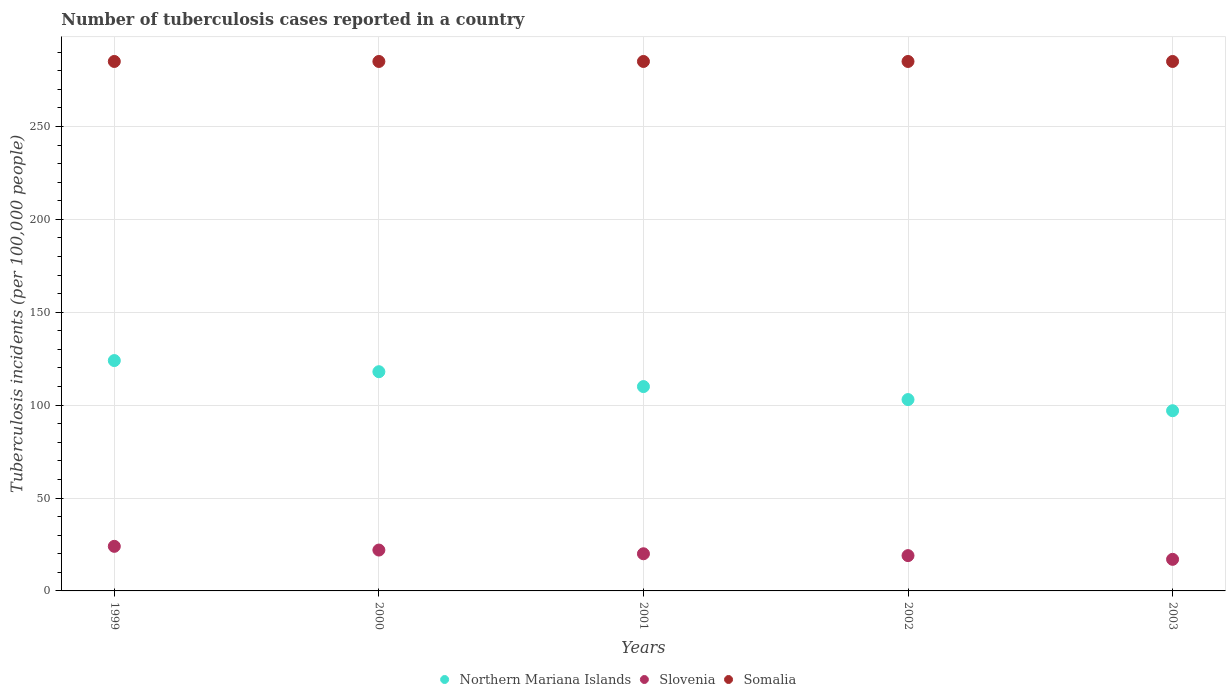Is the number of dotlines equal to the number of legend labels?
Make the answer very short. Yes. What is the number of tuberculosis cases reported in in Somalia in 1999?
Your answer should be compact. 285. Across all years, what is the maximum number of tuberculosis cases reported in in Somalia?
Offer a terse response. 285. Across all years, what is the minimum number of tuberculosis cases reported in in Northern Mariana Islands?
Keep it short and to the point. 97. In which year was the number of tuberculosis cases reported in in Northern Mariana Islands maximum?
Provide a succinct answer. 1999. In which year was the number of tuberculosis cases reported in in Slovenia minimum?
Your answer should be very brief. 2003. What is the total number of tuberculosis cases reported in in Slovenia in the graph?
Your answer should be very brief. 102. What is the average number of tuberculosis cases reported in in Slovenia per year?
Your response must be concise. 20.4. In the year 2000, what is the difference between the number of tuberculosis cases reported in in Somalia and number of tuberculosis cases reported in in Slovenia?
Your answer should be very brief. 263. What is the ratio of the number of tuberculosis cases reported in in Northern Mariana Islands in 1999 to that in 2003?
Provide a succinct answer. 1.28. Is the number of tuberculosis cases reported in in Northern Mariana Islands in 1999 less than that in 2001?
Make the answer very short. No. Is the difference between the number of tuberculosis cases reported in in Somalia in 2001 and 2003 greater than the difference between the number of tuberculosis cases reported in in Slovenia in 2001 and 2003?
Give a very brief answer. No. What is the difference between the highest and the second highest number of tuberculosis cases reported in in Slovenia?
Provide a short and direct response. 2. Is the sum of the number of tuberculosis cases reported in in Northern Mariana Islands in 2000 and 2003 greater than the maximum number of tuberculosis cases reported in in Slovenia across all years?
Your answer should be compact. Yes. Is it the case that in every year, the sum of the number of tuberculosis cases reported in in Northern Mariana Islands and number of tuberculosis cases reported in in Somalia  is greater than the number of tuberculosis cases reported in in Slovenia?
Your answer should be compact. Yes. Does the number of tuberculosis cases reported in in Northern Mariana Islands monotonically increase over the years?
Give a very brief answer. No. Is the number of tuberculosis cases reported in in Slovenia strictly less than the number of tuberculosis cases reported in in Northern Mariana Islands over the years?
Your answer should be very brief. Yes. How many dotlines are there?
Provide a short and direct response. 3. How many years are there in the graph?
Your response must be concise. 5. Does the graph contain any zero values?
Offer a terse response. No. Does the graph contain grids?
Give a very brief answer. Yes. How are the legend labels stacked?
Make the answer very short. Horizontal. What is the title of the graph?
Provide a succinct answer. Number of tuberculosis cases reported in a country. What is the label or title of the X-axis?
Your answer should be very brief. Years. What is the label or title of the Y-axis?
Offer a terse response. Tuberculosis incidents (per 100,0 people). What is the Tuberculosis incidents (per 100,000 people) in Northern Mariana Islands in 1999?
Your answer should be compact. 124. What is the Tuberculosis incidents (per 100,000 people) in Somalia in 1999?
Your answer should be compact. 285. What is the Tuberculosis incidents (per 100,000 people) in Northern Mariana Islands in 2000?
Offer a terse response. 118. What is the Tuberculosis incidents (per 100,000 people) of Slovenia in 2000?
Provide a succinct answer. 22. What is the Tuberculosis incidents (per 100,000 people) of Somalia in 2000?
Your answer should be compact. 285. What is the Tuberculosis incidents (per 100,000 people) in Northern Mariana Islands in 2001?
Keep it short and to the point. 110. What is the Tuberculosis incidents (per 100,000 people) of Somalia in 2001?
Your answer should be very brief. 285. What is the Tuberculosis incidents (per 100,000 people) in Northern Mariana Islands in 2002?
Offer a terse response. 103. What is the Tuberculosis incidents (per 100,000 people) in Slovenia in 2002?
Offer a terse response. 19. What is the Tuberculosis incidents (per 100,000 people) in Somalia in 2002?
Give a very brief answer. 285. What is the Tuberculosis incidents (per 100,000 people) in Northern Mariana Islands in 2003?
Offer a terse response. 97. What is the Tuberculosis incidents (per 100,000 people) in Slovenia in 2003?
Give a very brief answer. 17. What is the Tuberculosis incidents (per 100,000 people) of Somalia in 2003?
Provide a succinct answer. 285. Across all years, what is the maximum Tuberculosis incidents (per 100,000 people) of Northern Mariana Islands?
Your response must be concise. 124. Across all years, what is the maximum Tuberculosis incidents (per 100,000 people) in Slovenia?
Give a very brief answer. 24. Across all years, what is the maximum Tuberculosis incidents (per 100,000 people) in Somalia?
Offer a terse response. 285. Across all years, what is the minimum Tuberculosis incidents (per 100,000 people) in Northern Mariana Islands?
Provide a succinct answer. 97. Across all years, what is the minimum Tuberculosis incidents (per 100,000 people) in Somalia?
Ensure brevity in your answer.  285. What is the total Tuberculosis incidents (per 100,000 people) of Northern Mariana Islands in the graph?
Give a very brief answer. 552. What is the total Tuberculosis incidents (per 100,000 people) of Slovenia in the graph?
Your answer should be very brief. 102. What is the total Tuberculosis incidents (per 100,000 people) in Somalia in the graph?
Your answer should be very brief. 1425. What is the difference between the Tuberculosis incidents (per 100,000 people) of Northern Mariana Islands in 1999 and that in 2000?
Provide a short and direct response. 6. What is the difference between the Tuberculosis incidents (per 100,000 people) of Somalia in 1999 and that in 2000?
Keep it short and to the point. 0. What is the difference between the Tuberculosis incidents (per 100,000 people) of Northern Mariana Islands in 1999 and that in 2001?
Your answer should be compact. 14. What is the difference between the Tuberculosis incidents (per 100,000 people) of Slovenia in 1999 and that in 2001?
Offer a very short reply. 4. What is the difference between the Tuberculosis incidents (per 100,000 people) of Slovenia in 1999 and that in 2002?
Make the answer very short. 5. What is the difference between the Tuberculosis incidents (per 100,000 people) of Somalia in 1999 and that in 2002?
Keep it short and to the point. 0. What is the difference between the Tuberculosis incidents (per 100,000 people) of Northern Mariana Islands in 1999 and that in 2003?
Give a very brief answer. 27. What is the difference between the Tuberculosis incidents (per 100,000 people) of Somalia in 1999 and that in 2003?
Offer a terse response. 0. What is the difference between the Tuberculosis incidents (per 100,000 people) in Northern Mariana Islands in 2000 and that in 2001?
Your response must be concise. 8. What is the difference between the Tuberculosis incidents (per 100,000 people) of Slovenia in 2000 and that in 2001?
Offer a very short reply. 2. What is the difference between the Tuberculosis incidents (per 100,000 people) of Northern Mariana Islands in 2000 and that in 2002?
Your answer should be compact. 15. What is the difference between the Tuberculosis incidents (per 100,000 people) of Northern Mariana Islands in 2000 and that in 2003?
Give a very brief answer. 21. What is the difference between the Tuberculosis incidents (per 100,000 people) of Slovenia in 2000 and that in 2003?
Give a very brief answer. 5. What is the difference between the Tuberculosis incidents (per 100,000 people) of Northern Mariana Islands in 2001 and that in 2002?
Give a very brief answer. 7. What is the difference between the Tuberculosis incidents (per 100,000 people) in Northern Mariana Islands in 2002 and that in 2003?
Provide a short and direct response. 6. What is the difference between the Tuberculosis incidents (per 100,000 people) in Slovenia in 2002 and that in 2003?
Keep it short and to the point. 2. What is the difference between the Tuberculosis incidents (per 100,000 people) of Somalia in 2002 and that in 2003?
Your answer should be very brief. 0. What is the difference between the Tuberculosis incidents (per 100,000 people) of Northern Mariana Islands in 1999 and the Tuberculosis incidents (per 100,000 people) of Slovenia in 2000?
Give a very brief answer. 102. What is the difference between the Tuberculosis incidents (per 100,000 people) of Northern Mariana Islands in 1999 and the Tuberculosis incidents (per 100,000 people) of Somalia in 2000?
Provide a short and direct response. -161. What is the difference between the Tuberculosis incidents (per 100,000 people) of Slovenia in 1999 and the Tuberculosis incidents (per 100,000 people) of Somalia in 2000?
Offer a very short reply. -261. What is the difference between the Tuberculosis incidents (per 100,000 people) of Northern Mariana Islands in 1999 and the Tuberculosis incidents (per 100,000 people) of Slovenia in 2001?
Ensure brevity in your answer.  104. What is the difference between the Tuberculosis incidents (per 100,000 people) of Northern Mariana Islands in 1999 and the Tuberculosis incidents (per 100,000 people) of Somalia in 2001?
Your answer should be very brief. -161. What is the difference between the Tuberculosis incidents (per 100,000 people) of Slovenia in 1999 and the Tuberculosis incidents (per 100,000 people) of Somalia in 2001?
Ensure brevity in your answer.  -261. What is the difference between the Tuberculosis incidents (per 100,000 people) in Northern Mariana Islands in 1999 and the Tuberculosis incidents (per 100,000 people) in Slovenia in 2002?
Your response must be concise. 105. What is the difference between the Tuberculosis incidents (per 100,000 people) in Northern Mariana Islands in 1999 and the Tuberculosis incidents (per 100,000 people) in Somalia in 2002?
Keep it short and to the point. -161. What is the difference between the Tuberculosis incidents (per 100,000 people) in Slovenia in 1999 and the Tuberculosis incidents (per 100,000 people) in Somalia in 2002?
Your answer should be compact. -261. What is the difference between the Tuberculosis incidents (per 100,000 people) in Northern Mariana Islands in 1999 and the Tuberculosis incidents (per 100,000 people) in Slovenia in 2003?
Your answer should be compact. 107. What is the difference between the Tuberculosis incidents (per 100,000 people) in Northern Mariana Islands in 1999 and the Tuberculosis incidents (per 100,000 people) in Somalia in 2003?
Make the answer very short. -161. What is the difference between the Tuberculosis incidents (per 100,000 people) of Slovenia in 1999 and the Tuberculosis incidents (per 100,000 people) of Somalia in 2003?
Make the answer very short. -261. What is the difference between the Tuberculosis incidents (per 100,000 people) of Northern Mariana Islands in 2000 and the Tuberculosis incidents (per 100,000 people) of Slovenia in 2001?
Give a very brief answer. 98. What is the difference between the Tuberculosis incidents (per 100,000 people) of Northern Mariana Islands in 2000 and the Tuberculosis incidents (per 100,000 people) of Somalia in 2001?
Your response must be concise. -167. What is the difference between the Tuberculosis incidents (per 100,000 people) in Slovenia in 2000 and the Tuberculosis incidents (per 100,000 people) in Somalia in 2001?
Provide a short and direct response. -263. What is the difference between the Tuberculosis incidents (per 100,000 people) in Northern Mariana Islands in 2000 and the Tuberculosis incidents (per 100,000 people) in Slovenia in 2002?
Your response must be concise. 99. What is the difference between the Tuberculosis incidents (per 100,000 people) in Northern Mariana Islands in 2000 and the Tuberculosis incidents (per 100,000 people) in Somalia in 2002?
Provide a short and direct response. -167. What is the difference between the Tuberculosis incidents (per 100,000 people) of Slovenia in 2000 and the Tuberculosis incidents (per 100,000 people) of Somalia in 2002?
Provide a succinct answer. -263. What is the difference between the Tuberculosis incidents (per 100,000 people) of Northern Mariana Islands in 2000 and the Tuberculosis incidents (per 100,000 people) of Slovenia in 2003?
Offer a terse response. 101. What is the difference between the Tuberculosis incidents (per 100,000 people) of Northern Mariana Islands in 2000 and the Tuberculosis incidents (per 100,000 people) of Somalia in 2003?
Provide a short and direct response. -167. What is the difference between the Tuberculosis incidents (per 100,000 people) in Slovenia in 2000 and the Tuberculosis incidents (per 100,000 people) in Somalia in 2003?
Give a very brief answer. -263. What is the difference between the Tuberculosis incidents (per 100,000 people) of Northern Mariana Islands in 2001 and the Tuberculosis incidents (per 100,000 people) of Slovenia in 2002?
Provide a short and direct response. 91. What is the difference between the Tuberculosis incidents (per 100,000 people) in Northern Mariana Islands in 2001 and the Tuberculosis incidents (per 100,000 people) in Somalia in 2002?
Your response must be concise. -175. What is the difference between the Tuberculosis incidents (per 100,000 people) in Slovenia in 2001 and the Tuberculosis incidents (per 100,000 people) in Somalia in 2002?
Provide a short and direct response. -265. What is the difference between the Tuberculosis incidents (per 100,000 people) in Northern Mariana Islands in 2001 and the Tuberculosis incidents (per 100,000 people) in Slovenia in 2003?
Provide a short and direct response. 93. What is the difference between the Tuberculosis incidents (per 100,000 people) of Northern Mariana Islands in 2001 and the Tuberculosis incidents (per 100,000 people) of Somalia in 2003?
Your response must be concise. -175. What is the difference between the Tuberculosis incidents (per 100,000 people) in Slovenia in 2001 and the Tuberculosis incidents (per 100,000 people) in Somalia in 2003?
Your response must be concise. -265. What is the difference between the Tuberculosis incidents (per 100,000 people) in Northern Mariana Islands in 2002 and the Tuberculosis incidents (per 100,000 people) in Slovenia in 2003?
Make the answer very short. 86. What is the difference between the Tuberculosis incidents (per 100,000 people) of Northern Mariana Islands in 2002 and the Tuberculosis incidents (per 100,000 people) of Somalia in 2003?
Keep it short and to the point. -182. What is the difference between the Tuberculosis incidents (per 100,000 people) of Slovenia in 2002 and the Tuberculosis incidents (per 100,000 people) of Somalia in 2003?
Keep it short and to the point. -266. What is the average Tuberculosis incidents (per 100,000 people) in Northern Mariana Islands per year?
Keep it short and to the point. 110.4. What is the average Tuberculosis incidents (per 100,000 people) of Slovenia per year?
Provide a succinct answer. 20.4. What is the average Tuberculosis incidents (per 100,000 people) of Somalia per year?
Provide a short and direct response. 285. In the year 1999, what is the difference between the Tuberculosis incidents (per 100,000 people) in Northern Mariana Islands and Tuberculosis incidents (per 100,000 people) in Somalia?
Provide a succinct answer. -161. In the year 1999, what is the difference between the Tuberculosis incidents (per 100,000 people) of Slovenia and Tuberculosis incidents (per 100,000 people) of Somalia?
Give a very brief answer. -261. In the year 2000, what is the difference between the Tuberculosis incidents (per 100,000 people) in Northern Mariana Islands and Tuberculosis incidents (per 100,000 people) in Slovenia?
Provide a succinct answer. 96. In the year 2000, what is the difference between the Tuberculosis incidents (per 100,000 people) of Northern Mariana Islands and Tuberculosis incidents (per 100,000 people) of Somalia?
Your response must be concise. -167. In the year 2000, what is the difference between the Tuberculosis incidents (per 100,000 people) in Slovenia and Tuberculosis incidents (per 100,000 people) in Somalia?
Offer a very short reply. -263. In the year 2001, what is the difference between the Tuberculosis incidents (per 100,000 people) of Northern Mariana Islands and Tuberculosis incidents (per 100,000 people) of Somalia?
Give a very brief answer. -175. In the year 2001, what is the difference between the Tuberculosis incidents (per 100,000 people) of Slovenia and Tuberculosis incidents (per 100,000 people) of Somalia?
Your answer should be compact. -265. In the year 2002, what is the difference between the Tuberculosis incidents (per 100,000 people) in Northern Mariana Islands and Tuberculosis incidents (per 100,000 people) in Somalia?
Provide a short and direct response. -182. In the year 2002, what is the difference between the Tuberculosis incidents (per 100,000 people) of Slovenia and Tuberculosis incidents (per 100,000 people) of Somalia?
Offer a terse response. -266. In the year 2003, what is the difference between the Tuberculosis incidents (per 100,000 people) of Northern Mariana Islands and Tuberculosis incidents (per 100,000 people) of Somalia?
Offer a terse response. -188. In the year 2003, what is the difference between the Tuberculosis incidents (per 100,000 people) in Slovenia and Tuberculosis incidents (per 100,000 people) in Somalia?
Provide a succinct answer. -268. What is the ratio of the Tuberculosis incidents (per 100,000 people) in Northern Mariana Islands in 1999 to that in 2000?
Keep it short and to the point. 1.05. What is the ratio of the Tuberculosis incidents (per 100,000 people) of Somalia in 1999 to that in 2000?
Offer a terse response. 1. What is the ratio of the Tuberculosis incidents (per 100,000 people) of Northern Mariana Islands in 1999 to that in 2001?
Your response must be concise. 1.13. What is the ratio of the Tuberculosis incidents (per 100,000 people) of Slovenia in 1999 to that in 2001?
Ensure brevity in your answer.  1.2. What is the ratio of the Tuberculosis incidents (per 100,000 people) of Somalia in 1999 to that in 2001?
Your answer should be very brief. 1. What is the ratio of the Tuberculosis incidents (per 100,000 people) of Northern Mariana Islands in 1999 to that in 2002?
Offer a terse response. 1.2. What is the ratio of the Tuberculosis incidents (per 100,000 people) of Slovenia in 1999 to that in 2002?
Provide a short and direct response. 1.26. What is the ratio of the Tuberculosis incidents (per 100,000 people) of Somalia in 1999 to that in 2002?
Your answer should be compact. 1. What is the ratio of the Tuberculosis incidents (per 100,000 people) in Northern Mariana Islands in 1999 to that in 2003?
Give a very brief answer. 1.28. What is the ratio of the Tuberculosis incidents (per 100,000 people) of Slovenia in 1999 to that in 2003?
Provide a succinct answer. 1.41. What is the ratio of the Tuberculosis incidents (per 100,000 people) of Somalia in 1999 to that in 2003?
Provide a short and direct response. 1. What is the ratio of the Tuberculosis incidents (per 100,000 people) in Northern Mariana Islands in 2000 to that in 2001?
Make the answer very short. 1.07. What is the ratio of the Tuberculosis incidents (per 100,000 people) in Slovenia in 2000 to that in 2001?
Keep it short and to the point. 1.1. What is the ratio of the Tuberculosis incidents (per 100,000 people) of Northern Mariana Islands in 2000 to that in 2002?
Keep it short and to the point. 1.15. What is the ratio of the Tuberculosis incidents (per 100,000 people) of Slovenia in 2000 to that in 2002?
Your answer should be very brief. 1.16. What is the ratio of the Tuberculosis incidents (per 100,000 people) in Somalia in 2000 to that in 2002?
Your answer should be compact. 1. What is the ratio of the Tuberculosis incidents (per 100,000 people) in Northern Mariana Islands in 2000 to that in 2003?
Ensure brevity in your answer.  1.22. What is the ratio of the Tuberculosis incidents (per 100,000 people) in Slovenia in 2000 to that in 2003?
Your response must be concise. 1.29. What is the ratio of the Tuberculosis incidents (per 100,000 people) of Northern Mariana Islands in 2001 to that in 2002?
Your answer should be compact. 1.07. What is the ratio of the Tuberculosis incidents (per 100,000 people) of Slovenia in 2001 to that in 2002?
Your answer should be compact. 1.05. What is the ratio of the Tuberculosis incidents (per 100,000 people) of Northern Mariana Islands in 2001 to that in 2003?
Your answer should be compact. 1.13. What is the ratio of the Tuberculosis incidents (per 100,000 people) of Slovenia in 2001 to that in 2003?
Make the answer very short. 1.18. What is the ratio of the Tuberculosis incidents (per 100,000 people) of Somalia in 2001 to that in 2003?
Provide a short and direct response. 1. What is the ratio of the Tuberculosis incidents (per 100,000 people) in Northern Mariana Islands in 2002 to that in 2003?
Provide a short and direct response. 1.06. What is the ratio of the Tuberculosis incidents (per 100,000 people) of Slovenia in 2002 to that in 2003?
Provide a short and direct response. 1.12. What is the ratio of the Tuberculosis incidents (per 100,000 people) in Somalia in 2002 to that in 2003?
Keep it short and to the point. 1. What is the difference between the highest and the second highest Tuberculosis incidents (per 100,000 people) in Northern Mariana Islands?
Your response must be concise. 6. What is the difference between the highest and the second highest Tuberculosis incidents (per 100,000 people) in Slovenia?
Your answer should be very brief. 2. What is the difference between the highest and the second highest Tuberculosis incidents (per 100,000 people) in Somalia?
Your response must be concise. 0. What is the difference between the highest and the lowest Tuberculosis incidents (per 100,000 people) of Slovenia?
Give a very brief answer. 7. 